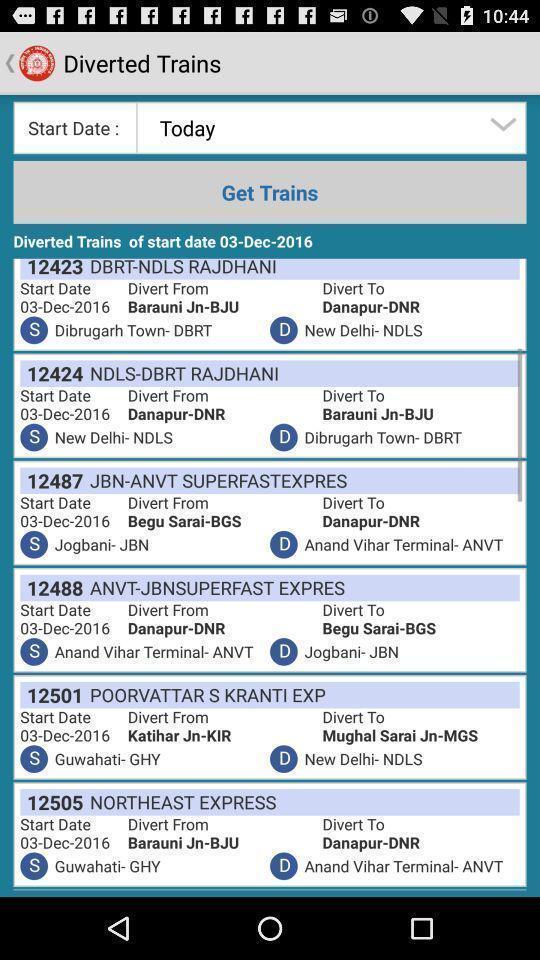Tell me what you see in this picture. Screen displaying the list of trains. 